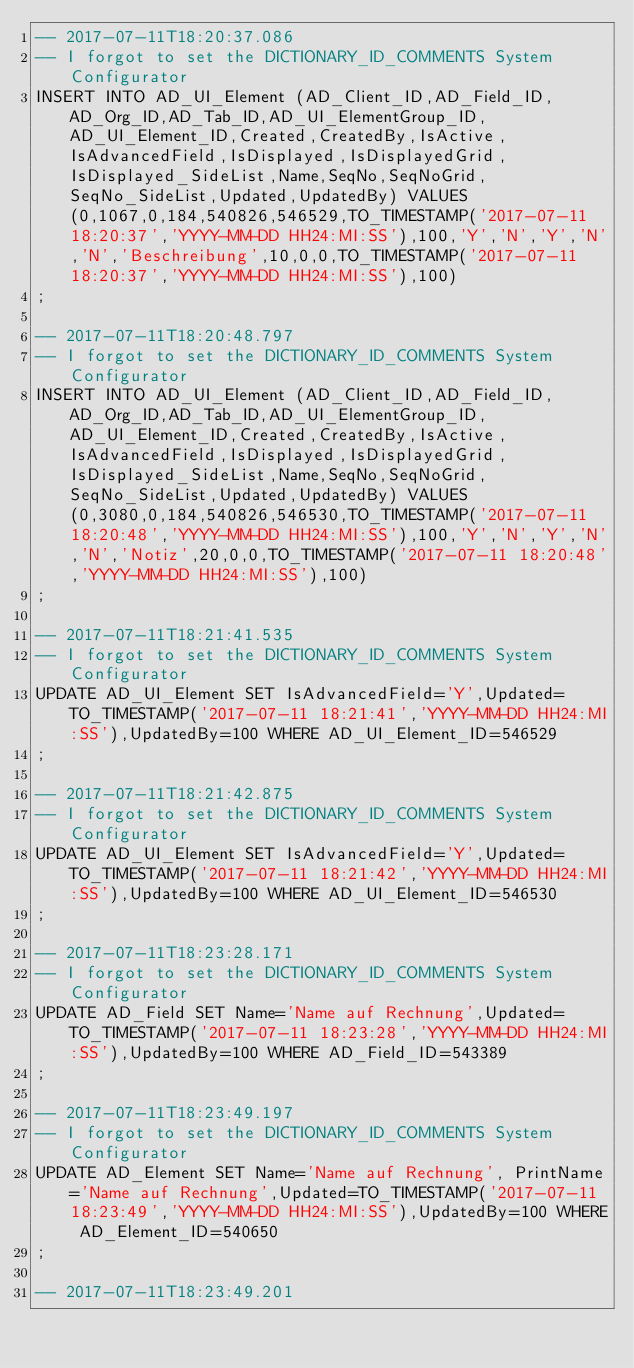<code> <loc_0><loc_0><loc_500><loc_500><_SQL_>-- 2017-07-11T18:20:37.086
-- I forgot to set the DICTIONARY_ID_COMMENTS System Configurator
INSERT INTO AD_UI_Element (AD_Client_ID,AD_Field_ID,AD_Org_ID,AD_Tab_ID,AD_UI_ElementGroup_ID,AD_UI_Element_ID,Created,CreatedBy,IsActive,IsAdvancedField,IsDisplayed,IsDisplayedGrid,IsDisplayed_SideList,Name,SeqNo,SeqNoGrid,SeqNo_SideList,Updated,UpdatedBy) VALUES (0,1067,0,184,540826,546529,TO_TIMESTAMP('2017-07-11 18:20:37','YYYY-MM-DD HH24:MI:SS'),100,'Y','N','Y','N','N','Beschreibung',10,0,0,TO_TIMESTAMP('2017-07-11 18:20:37','YYYY-MM-DD HH24:MI:SS'),100)
;

-- 2017-07-11T18:20:48.797
-- I forgot to set the DICTIONARY_ID_COMMENTS System Configurator
INSERT INTO AD_UI_Element (AD_Client_ID,AD_Field_ID,AD_Org_ID,AD_Tab_ID,AD_UI_ElementGroup_ID,AD_UI_Element_ID,Created,CreatedBy,IsActive,IsAdvancedField,IsDisplayed,IsDisplayedGrid,IsDisplayed_SideList,Name,SeqNo,SeqNoGrid,SeqNo_SideList,Updated,UpdatedBy) VALUES (0,3080,0,184,540826,546530,TO_TIMESTAMP('2017-07-11 18:20:48','YYYY-MM-DD HH24:MI:SS'),100,'Y','N','Y','N','N','Notiz',20,0,0,TO_TIMESTAMP('2017-07-11 18:20:48','YYYY-MM-DD HH24:MI:SS'),100)
;

-- 2017-07-11T18:21:41.535
-- I forgot to set the DICTIONARY_ID_COMMENTS System Configurator
UPDATE AD_UI_Element SET IsAdvancedField='Y',Updated=TO_TIMESTAMP('2017-07-11 18:21:41','YYYY-MM-DD HH24:MI:SS'),UpdatedBy=100 WHERE AD_UI_Element_ID=546529
;

-- 2017-07-11T18:21:42.875
-- I forgot to set the DICTIONARY_ID_COMMENTS System Configurator
UPDATE AD_UI_Element SET IsAdvancedField='Y',Updated=TO_TIMESTAMP('2017-07-11 18:21:42','YYYY-MM-DD HH24:MI:SS'),UpdatedBy=100 WHERE AD_UI_Element_ID=546530
;

-- 2017-07-11T18:23:28.171
-- I forgot to set the DICTIONARY_ID_COMMENTS System Configurator
UPDATE AD_Field SET Name='Name auf Rechnung',Updated=TO_TIMESTAMP('2017-07-11 18:23:28','YYYY-MM-DD HH24:MI:SS'),UpdatedBy=100 WHERE AD_Field_ID=543389
;

-- 2017-07-11T18:23:49.197
-- I forgot to set the DICTIONARY_ID_COMMENTS System Configurator
UPDATE AD_Element SET Name='Name auf Rechnung', PrintName='Name auf Rechnung',Updated=TO_TIMESTAMP('2017-07-11 18:23:49','YYYY-MM-DD HH24:MI:SS'),UpdatedBy=100 WHERE AD_Element_ID=540650
;

-- 2017-07-11T18:23:49.201</code> 